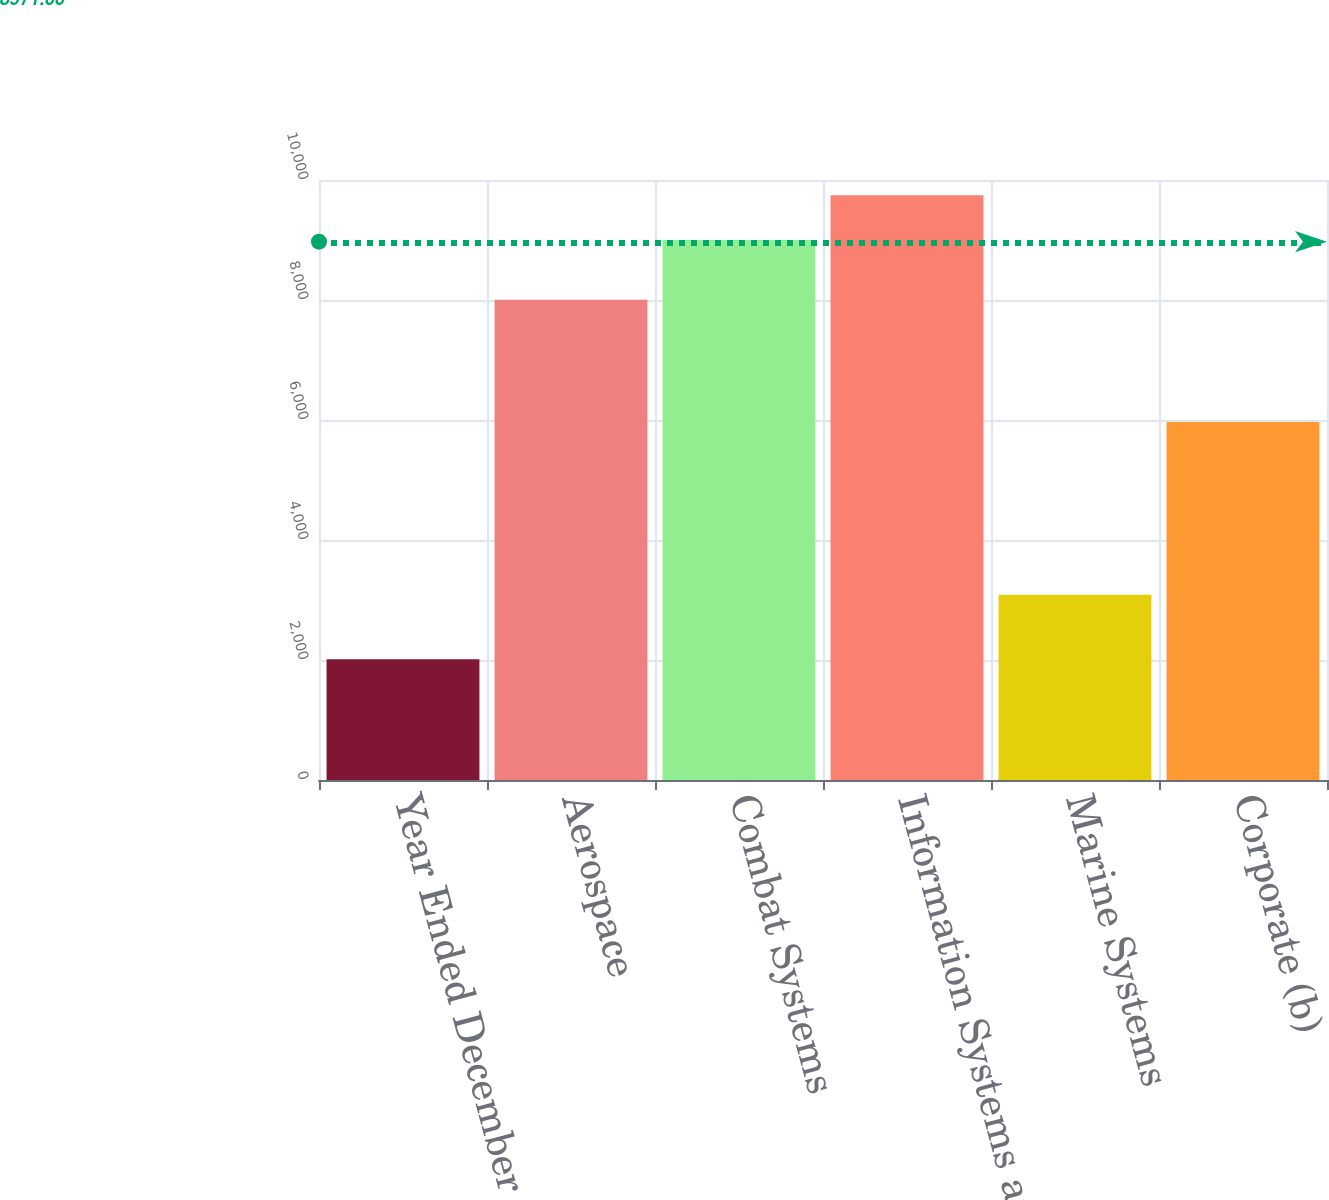Convert chart. <chart><loc_0><loc_0><loc_500><loc_500><bar_chart><fcel>Year Ended December 31<fcel>Aerospace<fcel>Combat Systems<fcel>Information Systems and<fcel>Marine Systems<fcel>Corporate (b)<nl><fcel>2013<fcel>8005<fcel>9002<fcel>9743.9<fcel>3088<fcel>5967<nl></chart> 